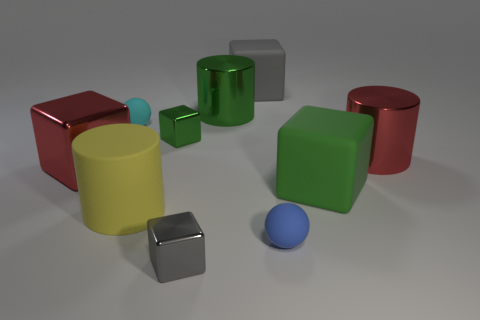What is the color of the cube that is in front of the yellow matte thing behind the tiny blue thing?
Make the answer very short. Gray. What is the material of the red object that is the same shape as the tiny gray shiny thing?
Offer a very short reply. Metal. How many metal objects are small green things or big red things?
Make the answer very short. 3. Do the tiny cube behind the large green cube and the tiny object right of the large green shiny object have the same material?
Make the answer very short. No. Are any small gray things visible?
Ensure brevity in your answer.  Yes. Is the shape of the big red thing on the right side of the tiny gray thing the same as the large green rubber object on the right side of the tiny gray metal block?
Offer a terse response. No. Is there a big green cylinder made of the same material as the tiny cyan sphere?
Make the answer very short. No. Does the cube that is left of the tiny cyan ball have the same material as the cyan ball?
Provide a short and direct response. No. Are there more tiny spheres in front of the gray metal block than matte blocks that are in front of the green rubber object?
Offer a terse response. No. The rubber cylinder that is the same size as the red block is what color?
Provide a succinct answer. Yellow. 